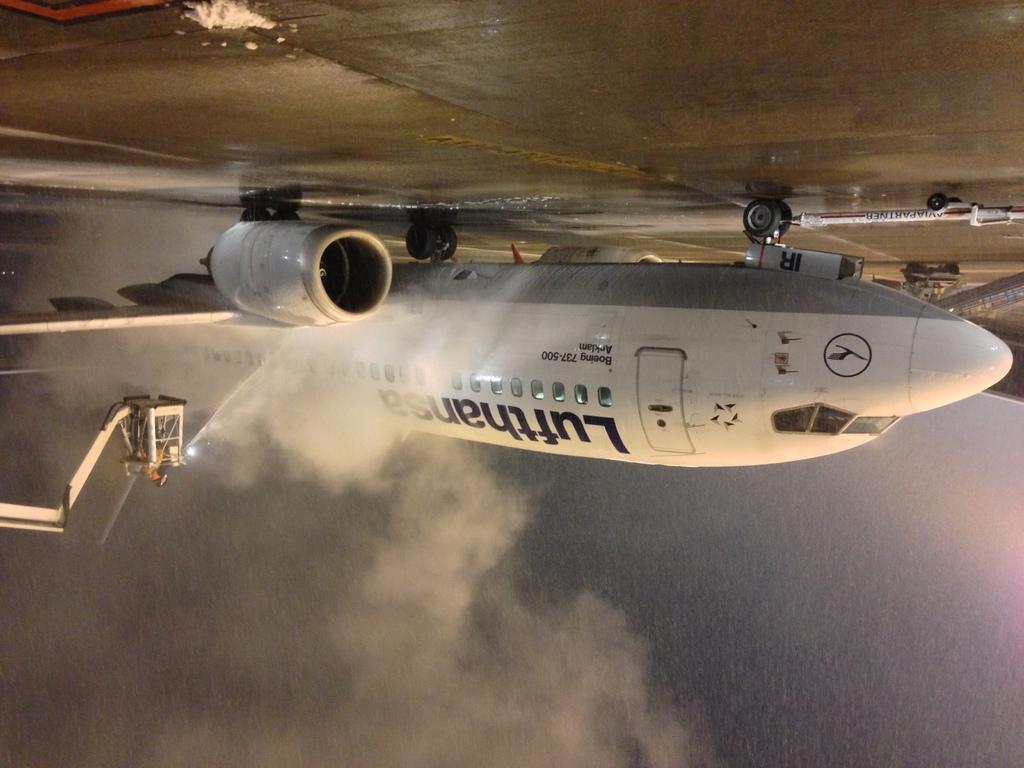What airline owns this plane?
Make the answer very short. Lufthansa. 